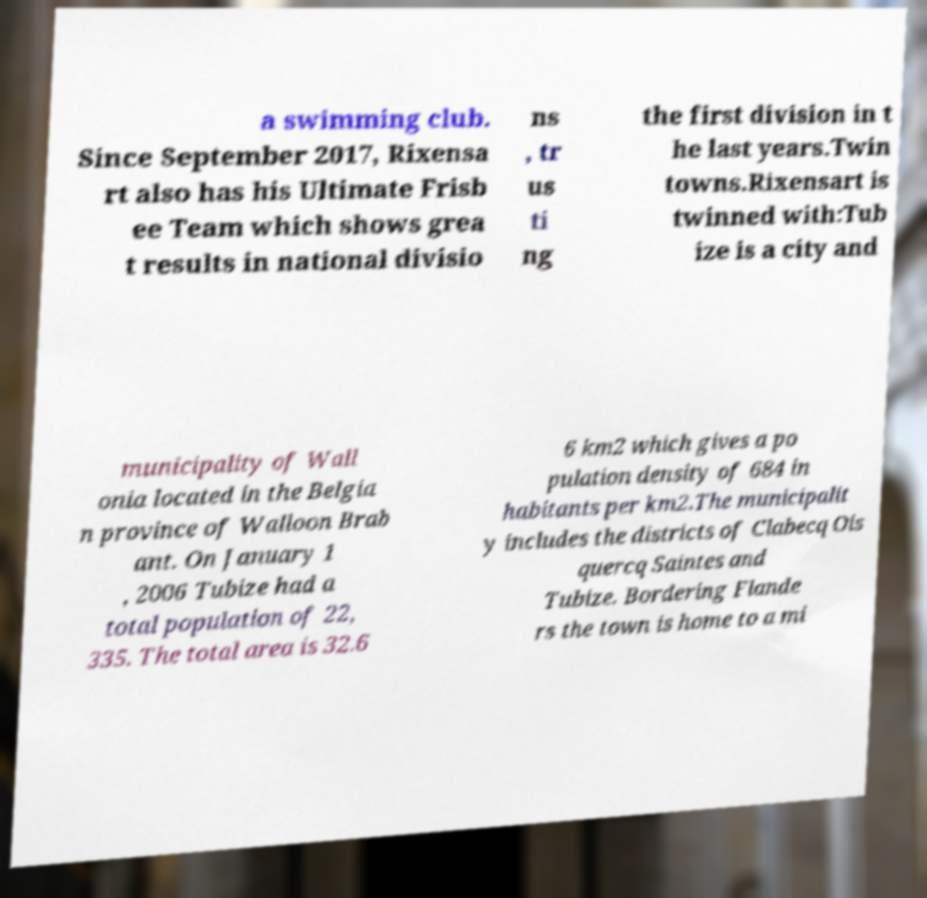Could you extract and type out the text from this image? a swimming club. Since September 2017, Rixensa rt also has his Ultimate Frisb ee Team which shows grea t results in national divisio ns , tr us ti ng the first division in t he last years.Twin towns.Rixensart is twinned with:Tub ize is a city and municipality of Wall onia located in the Belgia n province of Walloon Brab ant. On January 1 , 2006 Tubize had a total population of 22, 335. The total area is 32.6 6 km2 which gives a po pulation density of 684 in habitants per km2.The municipalit y includes the districts of Clabecq Ois quercq Saintes and Tubize. Bordering Flande rs the town is home to a mi 